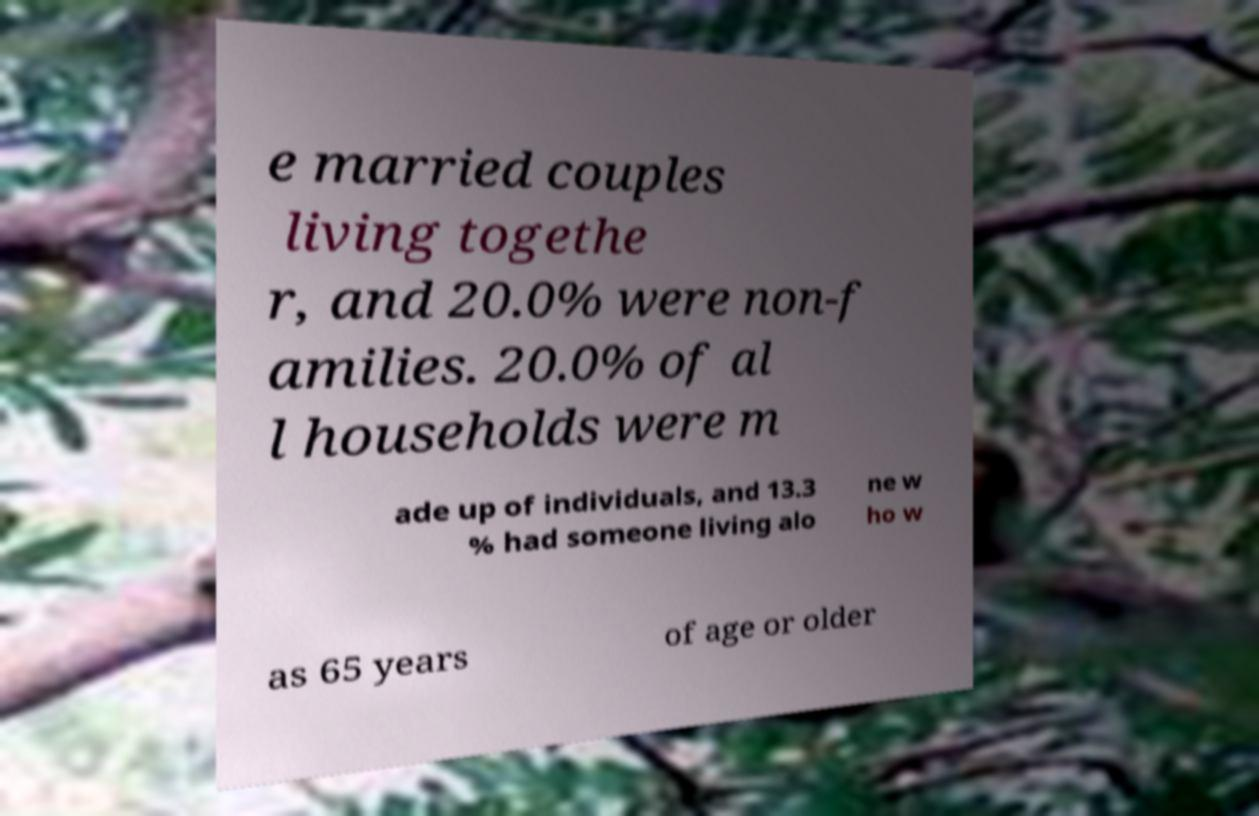Please identify and transcribe the text found in this image. e married couples living togethe r, and 20.0% were non-f amilies. 20.0% of al l households were m ade up of individuals, and 13.3 % had someone living alo ne w ho w as 65 years of age or older 